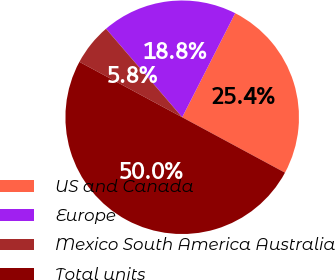Convert chart. <chart><loc_0><loc_0><loc_500><loc_500><pie_chart><fcel>US and Canada<fcel>Europe<fcel>Mexico South America Australia<fcel>Total units<nl><fcel>25.37%<fcel>18.81%<fcel>5.82%<fcel>50.0%<nl></chart> 